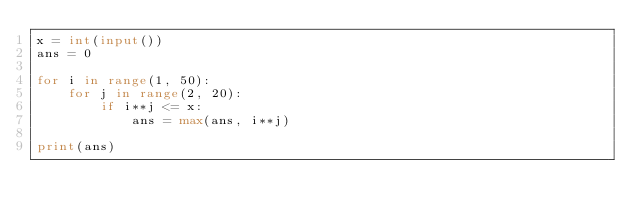<code> <loc_0><loc_0><loc_500><loc_500><_Python_>x = int(input())
ans = 0

for i in range(1, 50):
    for j in range(2, 20):
        if i**j <= x:
            ans = max(ans, i**j)

print(ans)</code> 